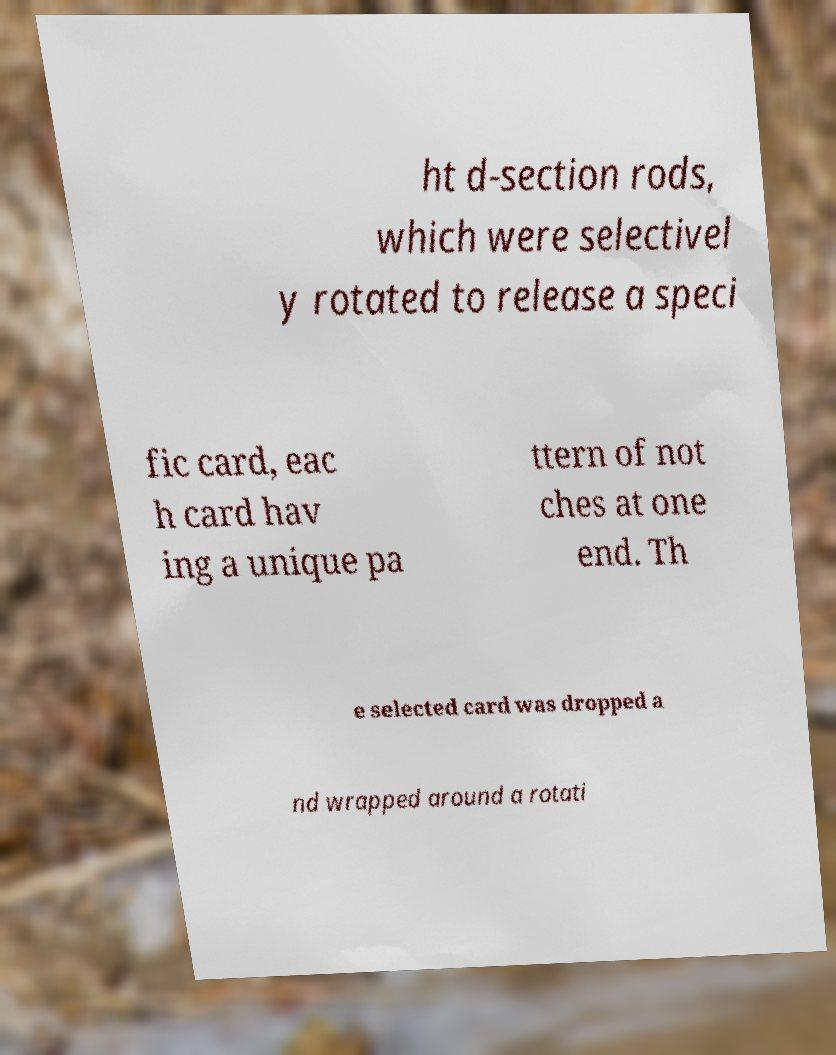Could you assist in decoding the text presented in this image and type it out clearly? ht d-section rods, which were selectivel y rotated to release a speci fic card, eac h card hav ing a unique pa ttern of not ches at one end. Th e selected card was dropped a nd wrapped around a rotati 